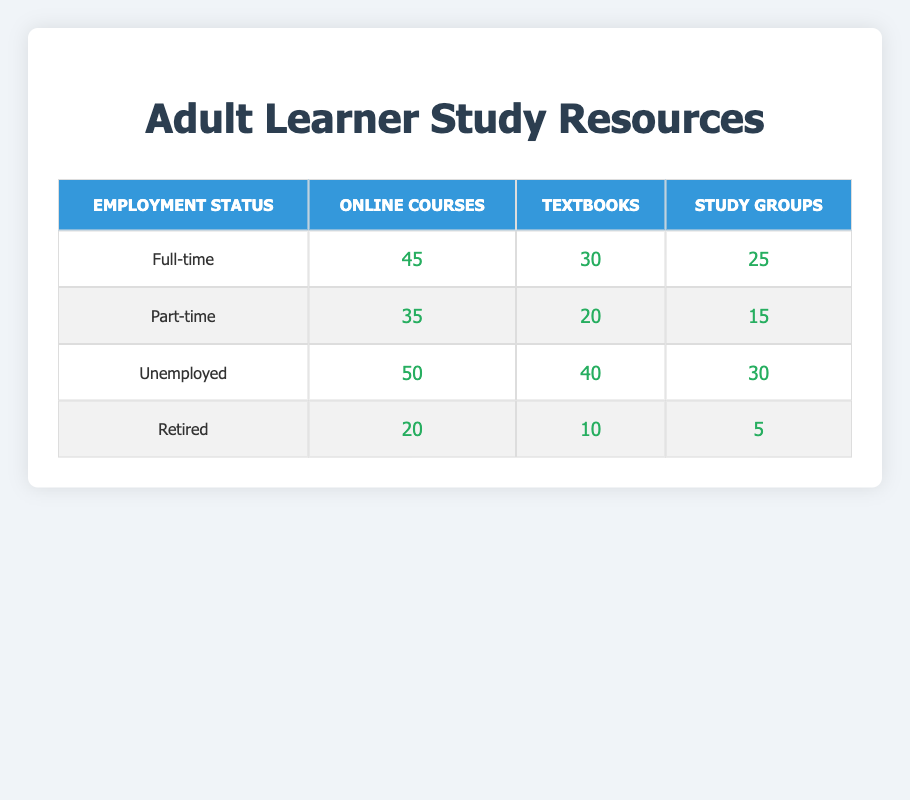What is the count of adult learners who prefer Online Courses while being Unemployed? In the table under the "Unemployed" row and "Online Courses" column, the count is shown as 50.
Answer: 50 Which employment status has the highest preference for Study Groups? Looking at the counts under the "Study Groups" column, "Unemployed" has the highest count of 30, compared to 25 for "Full-time," 15 for "Part-time," and 5 for "Retired."
Answer: Unemployed What is the total count of adult learners who prefer Textbooks across all employment statuses? To find the total count for "Textbooks," we add the counts: 30 (Full-time) + 20 (Part-time) + 40 (Unemployed) + 10 (Retired) = 100.
Answer: 100 Does the count of learners who prefer Study Groups differ between Full-time and Part-time employment statuses? For "Full-time," the count is 25, and for "Part-time," it's 15. Since 25 does not equal 15, they differ.
Answer: Yes What is the difference in counts between the preferred study resources for Online Courses by Unemployed and Full-time learners? The count for "Unemployed" is 50, and for "Full-time" it is 45. The difference is 50 - 45 = 5.
Answer: 5 What is the average count of adult learners preferring Textbooks across all employment statuses? The counts for "Textbooks" are 30, 20, 40, and 10; adding these gives 100. Since there are 4 categories, we divide by 4: 100/4 = 25.
Answer: 25 Is it true that the count of adult learners who prefer Online Courses is greater than those who prefer Study Groups for the Full-time category? The count for "Online Courses" under Full-time is 45, while for "Study Groups" it is 25. Since 45 is greater than 25, the statement is true.
Answer: Yes Which employment status has the least preference for any study resources? Examining all counts in the table, "Retired" has the lowest counts of 20 for Online Courses, 10 for Textbooks, and 5 for Study Groups, thus has the least preference overall.
Answer: Retired 